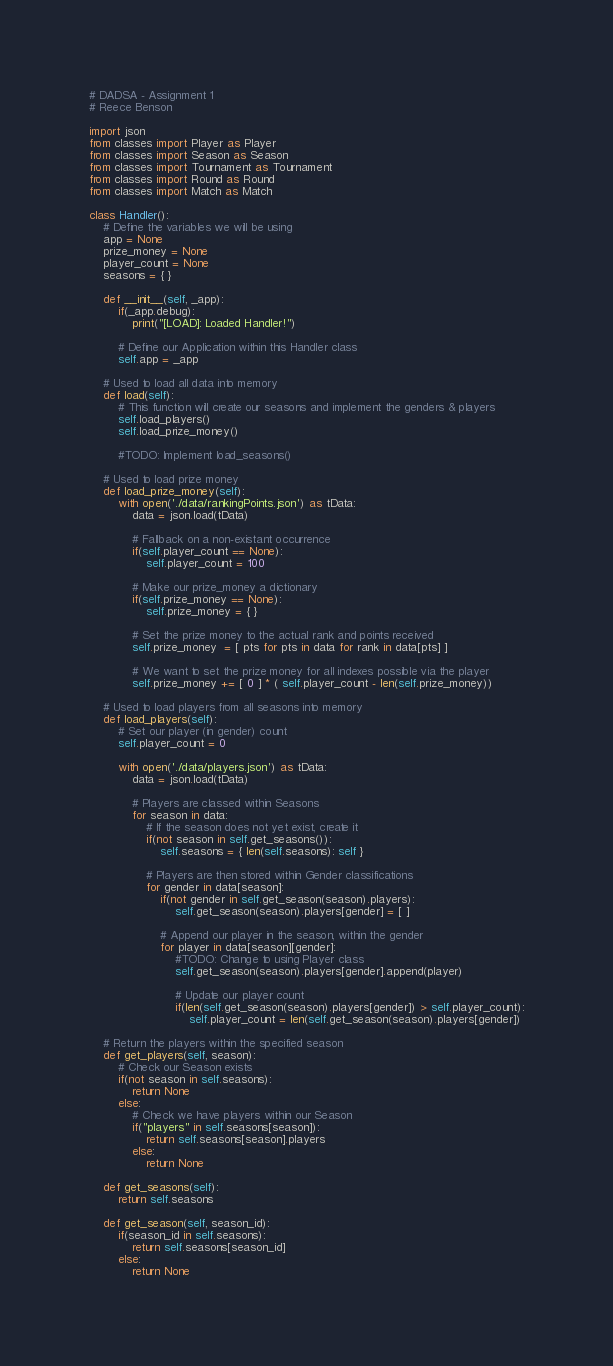<code> <loc_0><loc_0><loc_500><loc_500><_Python_># DADSA - Assignment 1
# Reece Benson

import json
from classes import Player as Player
from classes import Season as Season
from classes import Tournament as Tournament
from classes import Round as Round
from classes import Match as Match

class Handler():
    # Define the variables we will be using
    app = None
    prize_money = None
    player_count = None
    seasons = { }

    def __init__(self, _app):
        if(_app.debug):
            print("[LOAD]: Loaded Handler!")

        # Define our Application within this Handler class
        self.app = _app

    # Used to load all data into memory
    def load(self):
        # This function will create our seasons and implement the genders & players
        self.load_players()
        self.load_prize_money()

        #TODO: Implement load_seasons()

    # Used to load prize money
    def load_prize_money(self):
        with open('./data/rankingPoints.json') as tData:
            data = json.load(tData)

            # Fallback on a non-existant occurrence
            if(self.player_count == None):
                self.player_count = 100

            # Make our prize_money a dictionary
            if(self.prize_money == None):
                self.prize_money = { }

            # Set the prize money to the actual rank and points received
            self.prize_money  = [ pts for pts in data for rank in data[pts] ]

            # We want to set the prize money for all indexes possible via the player
            self.prize_money += [ 0 ] * ( self.player_count - len(self.prize_money))

    # Used to load players from all seasons into memory
    def load_players(self):
        # Set our player (in gender) count
        self.player_count = 0

        with open('./data/players.json') as tData:
            data = json.load(tData)

            # Players are classed within Seasons
            for season in data:
                # If the season does not yet exist, create it
                if(not season in self.get_seasons()):
                    self.seasons = { len(self.seasons): self }

                # Players are then stored within Gender classifications
                for gender in data[season]:
                    if(not gender in self.get_season(season).players):
                        self.get_season(season).players[gender] = [ ]

                    # Append our player in the season, within the gender
                    for player in data[season][gender]:
                        #TODO: Change to using Player class
                        self.get_season(season).players[gender].append(player)

                        # Update our player count
                        if(len(self.get_season(season).players[gender]) > self.player_count):
                            self.player_count = len(self.get_season(season).players[gender])

    # Return the players within the specified season
    def get_players(self, season):
        # Check our Season exists
        if(not season in self.seasons):
            return None
        else:
            # Check we have players within our Season
            if("players" in self.seasons[season]):
                return self.seasons[season].players
            else:
                return None

    def get_seasons(self):
        return self.seasons

    def get_season(self, season_id):
        if(season_id in self.seasons):
            return self.seasons[season_id]
        else:
            return None</code> 